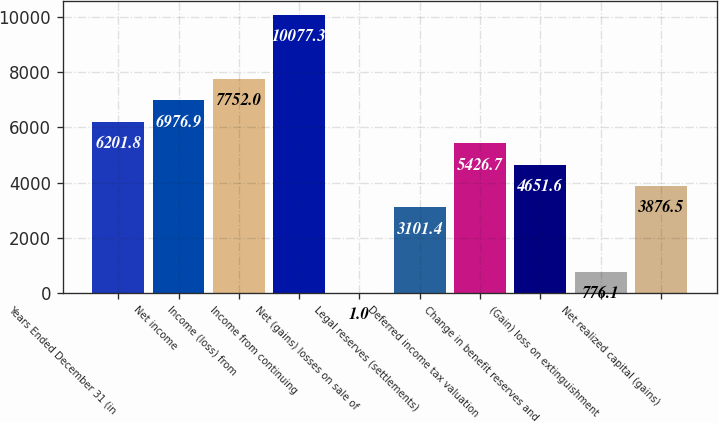<chart> <loc_0><loc_0><loc_500><loc_500><bar_chart><fcel>Years Ended December 31 (in<fcel>Net income<fcel>Income (loss) from<fcel>Income from continuing<fcel>Net (gains) losses on sale of<fcel>Legal reserves (settlements)<fcel>Deferred income tax valuation<fcel>Change in benefit reserves and<fcel>(Gain) loss on extinguishment<fcel>Net realized capital (gains)<nl><fcel>6201.8<fcel>6976.9<fcel>7752<fcel>10077.3<fcel>1<fcel>3101.4<fcel>5426.7<fcel>4651.6<fcel>776.1<fcel>3876.5<nl></chart> 